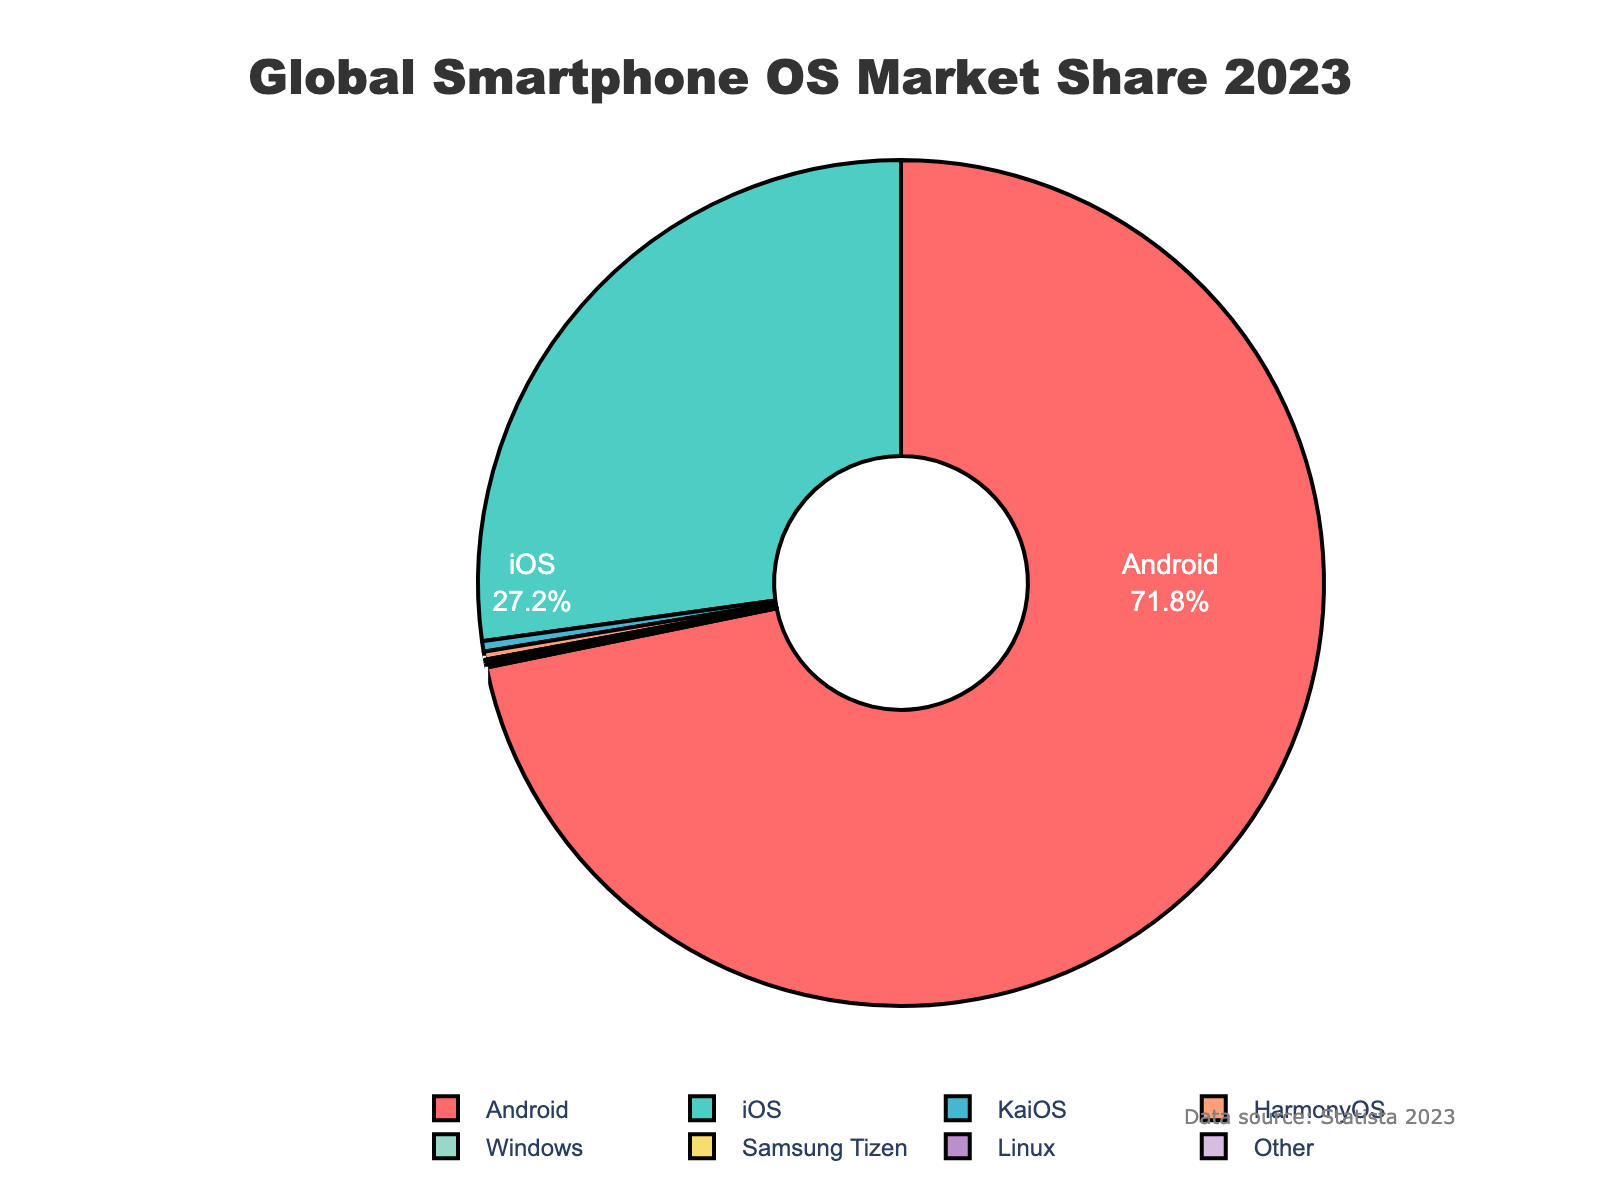What's the market share of Android in 2023? The figure shows the market shares of various smartphone operating systems as percentages. Android is labeled with a percentage in the chart.
Answer: 71.8% What is the combined market share of KaiOS and HarmonyOS? To find the combined market share, add the market shares of KaiOS (0.4%) and HarmonyOS (0.3%). 0.4 + 0.3 = 0.7
Answer: 0.7% Which operating system has the smallest market share? The figure shows market shares for several operating systems. Among them, both Windows and Samsung Tizen have the smallest market share at 0.1% each.
Answer: Windows and Samsung Tizen How much larger is iOS's market share compared to KaiOS's market share? Subtract KaiOS's market share (0.4%) from iOS's market share (27.2%) to find the difference. 27.2 - 0.4 = 26.8
Answer: 26.8% What percentage of the market is not occupied by Android and iOS combined? First, sum the market shares of Android (71.8%) and iOS (27.2%). The combined share is 99%. Then, subtract this from 100% to find the remainder. 100 - 99 = 1
Answer: 1% Which operating system is represented with the second most saturated color? In the figure, each operating system is shown in different colors. The second most saturated color after Android (which is red) is likely iOS, which is represented in green.
Answer: iOS If the market share of 'Other' was twice as large, what would it be? To find the new market share, multiply the current market share of 'Other' (0.05%) by 2. 0.05 * 2 = 0.1
Answer: 0.1% Is the market share of Linux greater than or equal to the market share of Samsung Tizen? The market share of Linux (0.05%) is compared to that of Samsung Tizen (0.1%). 0.05 is less than 0.1, thus it is not greater than or equal.
Answer: No Which three operating systems have combined market shares less than 1%? By adding their market shares: KaiOS (0.4%), HarmonyOS (0.3%), and Windows (0.1%). The sum is 0.4 + 0.3 + 0.1 = 0.8, which is less than 1%.
Answer: KaiOS, HarmonyOS, Windows 